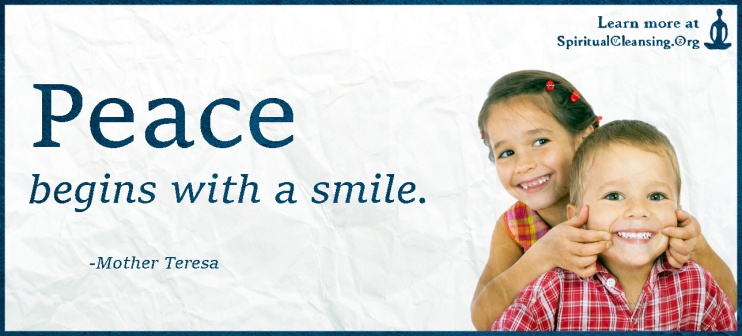What could be the backstory of the website mentioned in the image, SpiritualCleansing.org? SpiritualCleansing.org could have originated from the vision of a compassionate individual—let's call her Grace—who had gone through significant personal challenges and sought solace in various spiritual practices. After discovering the transformative power of mindfulness, meditation, and acts of kindness, Grace felt inspired to share her journey with others. She believed that everyone deserved to experience peace and happiness, regardless of their circumstances. Grace created SpiritualCleansing.org as a sanctuary for people seeking spiritual upliftment and emotional healing. The website offers a rich array of resources, including guided meditations, inspirational articles, and forums for sharing personal stories. With a mission to spread light and positivity, Grace's website has become a beacon of hope for many, fostering a supportive community where peace truly begins with a smile. 